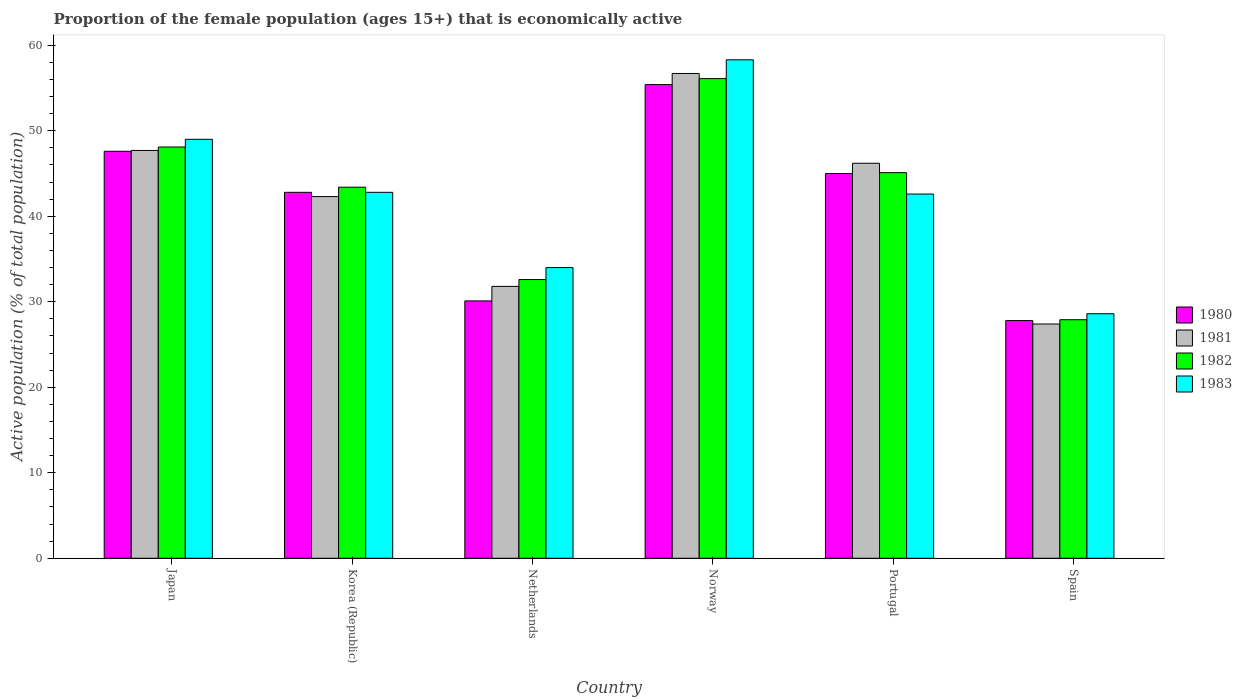How many groups of bars are there?
Offer a terse response. 6. Are the number of bars on each tick of the X-axis equal?
Ensure brevity in your answer.  Yes. What is the proportion of the female population that is economically active in 1981 in Spain?
Provide a short and direct response. 27.4. Across all countries, what is the maximum proportion of the female population that is economically active in 1983?
Your answer should be compact. 58.3. Across all countries, what is the minimum proportion of the female population that is economically active in 1981?
Ensure brevity in your answer.  27.4. What is the total proportion of the female population that is economically active in 1981 in the graph?
Provide a short and direct response. 252.1. What is the difference between the proportion of the female population that is economically active in 1981 in Korea (Republic) and that in Norway?
Your answer should be very brief. -14.4. What is the difference between the proportion of the female population that is economically active in 1980 in Spain and the proportion of the female population that is economically active in 1983 in Japan?
Your answer should be very brief. -21.2. What is the average proportion of the female population that is economically active in 1981 per country?
Give a very brief answer. 42.02. What is the difference between the proportion of the female population that is economically active of/in 1982 and proportion of the female population that is economically active of/in 1981 in Japan?
Your answer should be very brief. 0.4. What is the ratio of the proportion of the female population that is economically active in 1981 in Norway to that in Spain?
Your response must be concise. 2.07. Is the proportion of the female population that is economically active in 1982 in Japan less than that in Korea (Republic)?
Your response must be concise. No. Is the difference between the proportion of the female population that is economically active in 1982 in Japan and Korea (Republic) greater than the difference between the proportion of the female population that is economically active in 1981 in Japan and Korea (Republic)?
Offer a terse response. No. What is the difference between the highest and the second highest proportion of the female population that is economically active in 1980?
Provide a short and direct response. -2.6. What is the difference between the highest and the lowest proportion of the female population that is economically active in 1981?
Give a very brief answer. 29.3. In how many countries, is the proportion of the female population that is economically active in 1983 greater than the average proportion of the female population that is economically active in 1983 taken over all countries?
Offer a very short reply. 4. What does the 2nd bar from the left in Korea (Republic) represents?
Your answer should be very brief. 1981. How many countries are there in the graph?
Provide a succinct answer. 6. What is the difference between two consecutive major ticks on the Y-axis?
Offer a very short reply. 10. Does the graph contain grids?
Your answer should be compact. No. How many legend labels are there?
Make the answer very short. 4. How are the legend labels stacked?
Provide a short and direct response. Vertical. What is the title of the graph?
Offer a very short reply. Proportion of the female population (ages 15+) that is economically active. Does "1983" appear as one of the legend labels in the graph?
Provide a short and direct response. Yes. What is the label or title of the X-axis?
Your answer should be compact. Country. What is the label or title of the Y-axis?
Your answer should be very brief. Active population (% of total population). What is the Active population (% of total population) of 1980 in Japan?
Provide a short and direct response. 47.6. What is the Active population (% of total population) of 1981 in Japan?
Give a very brief answer. 47.7. What is the Active population (% of total population) in 1982 in Japan?
Ensure brevity in your answer.  48.1. What is the Active population (% of total population) of 1983 in Japan?
Your response must be concise. 49. What is the Active population (% of total population) in 1980 in Korea (Republic)?
Your answer should be compact. 42.8. What is the Active population (% of total population) of 1981 in Korea (Republic)?
Give a very brief answer. 42.3. What is the Active population (% of total population) of 1982 in Korea (Republic)?
Give a very brief answer. 43.4. What is the Active population (% of total population) of 1983 in Korea (Republic)?
Keep it short and to the point. 42.8. What is the Active population (% of total population) in 1980 in Netherlands?
Your response must be concise. 30.1. What is the Active population (% of total population) of 1981 in Netherlands?
Ensure brevity in your answer.  31.8. What is the Active population (% of total population) of 1982 in Netherlands?
Make the answer very short. 32.6. What is the Active population (% of total population) in 1983 in Netherlands?
Provide a short and direct response. 34. What is the Active population (% of total population) in 1980 in Norway?
Give a very brief answer. 55.4. What is the Active population (% of total population) in 1981 in Norway?
Ensure brevity in your answer.  56.7. What is the Active population (% of total population) in 1982 in Norway?
Offer a very short reply. 56.1. What is the Active population (% of total population) of 1983 in Norway?
Your response must be concise. 58.3. What is the Active population (% of total population) of 1980 in Portugal?
Your answer should be very brief. 45. What is the Active population (% of total population) of 1981 in Portugal?
Your response must be concise. 46.2. What is the Active population (% of total population) of 1982 in Portugal?
Offer a terse response. 45.1. What is the Active population (% of total population) in 1983 in Portugal?
Keep it short and to the point. 42.6. What is the Active population (% of total population) of 1980 in Spain?
Offer a terse response. 27.8. What is the Active population (% of total population) of 1981 in Spain?
Offer a very short reply. 27.4. What is the Active population (% of total population) in 1982 in Spain?
Provide a short and direct response. 27.9. What is the Active population (% of total population) of 1983 in Spain?
Your answer should be very brief. 28.6. Across all countries, what is the maximum Active population (% of total population) in 1980?
Your answer should be compact. 55.4. Across all countries, what is the maximum Active population (% of total population) of 1981?
Provide a succinct answer. 56.7. Across all countries, what is the maximum Active population (% of total population) in 1982?
Provide a short and direct response. 56.1. Across all countries, what is the maximum Active population (% of total population) in 1983?
Offer a very short reply. 58.3. Across all countries, what is the minimum Active population (% of total population) of 1980?
Keep it short and to the point. 27.8. Across all countries, what is the minimum Active population (% of total population) in 1981?
Provide a succinct answer. 27.4. Across all countries, what is the minimum Active population (% of total population) of 1982?
Ensure brevity in your answer.  27.9. Across all countries, what is the minimum Active population (% of total population) of 1983?
Give a very brief answer. 28.6. What is the total Active population (% of total population) of 1980 in the graph?
Give a very brief answer. 248.7. What is the total Active population (% of total population) of 1981 in the graph?
Your answer should be very brief. 252.1. What is the total Active population (% of total population) of 1982 in the graph?
Ensure brevity in your answer.  253.2. What is the total Active population (% of total population) of 1983 in the graph?
Keep it short and to the point. 255.3. What is the difference between the Active population (% of total population) in 1983 in Japan and that in Korea (Republic)?
Your response must be concise. 6.2. What is the difference between the Active population (% of total population) in 1980 in Japan and that in Netherlands?
Offer a very short reply. 17.5. What is the difference between the Active population (% of total population) of 1982 in Japan and that in Netherlands?
Offer a very short reply. 15.5. What is the difference between the Active population (% of total population) of 1983 in Japan and that in Netherlands?
Give a very brief answer. 15. What is the difference between the Active population (% of total population) in 1980 in Japan and that in Portugal?
Give a very brief answer. 2.6. What is the difference between the Active population (% of total population) of 1982 in Japan and that in Portugal?
Your answer should be compact. 3. What is the difference between the Active population (% of total population) in 1983 in Japan and that in Portugal?
Provide a short and direct response. 6.4. What is the difference between the Active population (% of total population) in 1980 in Japan and that in Spain?
Your response must be concise. 19.8. What is the difference between the Active population (% of total population) in 1981 in Japan and that in Spain?
Provide a succinct answer. 20.3. What is the difference between the Active population (% of total population) in 1982 in Japan and that in Spain?
Offer a very short reply. 20.2. What is the difference between the Active population (% of total population) in 1983 in Japan and that in Spain?
Give a very brief answer. 20.4. What is the difference between the Active population (% of total population) of 1980 in Korea (Republic) and that in Netherlands?
Your response must be concise. 12.7. What is the difference between the Active population (% of total population) of 1980 in Korea (Republic) and that in Norway?
Ensure brevity in your answer.  -12.6. What is the difference between the Active population (% of total population) of 1981 in Korea (Republic) and that in Norway?
Offer a very short reply. -14.4. What is the difference between the Active population (% of total population) of 1982 in Korea (Republic) and that in Norway?
Offer a terse response. -12.7. What is the difference between the Active population (% of total population) in 1983 in Korea (Republic) and that in Norway?
Your answer should be compact. -15.5. What is the difference between the Active population (% of total population) of 1980 in Korea (Republic) and that in Portugal?
Your response must be concise. -2.2. What is the difference between the Active population (% of total population) in 1983 in Korea (Republic) and that in Portugal?
Ensure brevity in your answer.  0.2. What is the difference between the Active population (% of total population) of 1981 in Korea (Republic) and that in Spain?
Make the answer very short. 14.9. What is the difference between the Active population (% of total population) of 1983 in Korea (Republic) and that in Spain?
Give a very brief answer. 14.2. What is the difference between the Active population (% of total population) in 1980 in Netherlands and that in Norway?
Ensure brevity in your answer.  -25.3. What is the difference between the Active population (% of total population) in 1981 in Netherlands and that in Norway?
Provide a succinct answer. -24.9. What is the difference between the Active population (% of total population) of 1982 in Netherlands and that in Norway?
Keep it short and to the point. -23.5. What is the difference between the Active population (% of total population) in 1983 in Netherlands and that in Norway?
Offer a terse response. -24.3. What is the difference between the Active population (% of total population) of 1980 in Netherlands and that in Portugal?
Offer a terse response. -14.9. What is the difference between the Active population (% of total population) in 1981 in Netherlands and that in Portugal?
Make the answer very short. -14.4. What is the difference between the Active population (% of total population) in 1982 in Netherlands and that in Portugal?
Your answer should be very brief. -12.5. What is the difference between the Active population (% of total population) of 1981 in Netherlands and that in Spain?
Offer a terse response. 4.4. What is the difference between the Active population (% of total population) in 1983 in Netherlands and that in Spain?
Your answer should be very brief. 5.4. What is the difference between the Active population (% of total population) of 1980 in Norway and that in Portugal?
Provide a short and direct response. 10.4. What is the difference between the Active population (% of total population) in 1981 in Norway and that in Portugal?
Offer a very short reply. 10.5. What is the difference between the Active population (% of total population) of 1980 in Norway and that in Spain?
Your answer should be very brief. 27.6. What is the difference between the Active population (% of total population) in 1981 in Norway and that in Spain?
Provide a succinct answer. 29.3. What is the difference between the Active population (% of total population) of 1982 in Norway and that in Spain?
Give a very brief answer. 28.2. What is the difference between the Active population (% of total population) of 1983 in Norway and that in Spain?
Ensure brevity in your answer.  29.7. What is the difference between the Active population (% of total population) of 1980 in Portugal and that in Spain?
Give a very brief answer. 17.2. What is the difference between the Active population (% of total population) in 1981 in Portugal and that in Spain?
Ensure brevity in your answer.  18.8. What is the difference between the Active population (% of total population) of 1983 in Portugal and that in Spain?
Offer a very short reply. 14. What is the difference between the Active population (% of total population) of 1981 in Japan and the Active population (% of total population) of 1982 in Korea (Republic)?
Provide a short and direct response. 4.3. What is the difference between the Active population (% of total population) of 1982 in Japan and the Active population (% of total population) of 1983 in Korea (Republic)?
Provide a short and direct response. 5.3. What is the difference between the Active population (% of total population) of 1980 in Japan and the Active population (% of total population) of 1983 in Netherlands?
Make the answer very short. 13.6. What is the difference between the Active population (% of total population) in 1981 in Japan and the Active population (% of total population) in 1983 in Netherlands?
Offer a terse response. 13.7. What is the difference between the Active population (% of total population) in 1980 in Japan and the Active population (% of total population) in 1981 in Norway?
Make the answer very short. -9.1. What is the difference between the Active population (% of total population) in 1980 in Japan and the Active population (% of total population) in 1983 in Norway?
Give a very brief answer. -10.7. What is the difference between the Active population (% of total population) in 1980 in Japan and the Active population (% of total population) in 1981 in Portugal?
Ensure brevity in your answer.  1.4. What is the difference between the Active population (% of total population) of 1980 in Japan and the Active population (% of total population) of 1982 in Portugal?
Provide a succinct answer. 2.5. What is the difference between the Active population (% of total population) of 1980 in Japan and the Active population (% of total population) of 1983 in Portugal?
Make the answer very short. 5. What is the difference between the Active population (% of total population) of 1981 in Japan and the Active population (% of total population) of 1982 in Portugal?
Keep it short and to the point. 2.6. What is the difference between the Active population (% of total population) of 1981 in Japan and the Active population (% of total population) of 1983 in Portugal?
Your answer should be compact. 5.1. What is the difference between the Active population (% of total population) of 1980 in Japan and the Active population (% of total population) of 1981 in Spain?
Provide a short and direct response. 20.2. What is the difference between the Active population (% of total population) in 1980 in Japan and the Active population (% of total population) in 1983 in Spain?
Your response must be concise. 19. What is the difference between the Active population (% of total population) of 1981 in Japan and the Active population (% of total population) of 1982 in Spain?
Your answer should be very brief. 19.8. What is the difference between the Active population (% of total population) in 1981 in Japan and the Active population (% of total population) in 1983 in Spain?
Ensure brevity in your answer.  19.1. What is the difference between the Active population (% of total population) of 1982 in Japan and the Active population (% of total population) of 1983 in Spain?
Your response must be concise. 19.5. What is the difference between the Active population (% of total population) in 1980 in Korea (Republic) and the Active population (% of total population) in 1981 in Netherlands?
Provide a short and direct response. 11. What is the difference between the Active population (% of total population) in 1980 in Korea (Republic) and the Active population (% of total population) in 1983 in Netherlands?
Offer a very short reply. 8.8. What is the difference between the Active population (% of total population) of 1981 in Korea (Republic) and the Active population (% of total population) of 1983 in Netherlands?
Your answer should be very brief. 8.3. What is the difference between the Active population (% of total population) of 1980 in Korea (Republic) and the Active population (% of total population) of 1983 in Norway?
Provide a succinct answer. -15.5. What is the difference between the Active population (% of total population) of 1981 in Korea (Republic) and the Active population (% of total population) of 1982 in Norway?
Your answer should be compact. -13.8. What is the difference between the Active population (% of total population) in 1981 in Korea (Republic) and the Active population (% of total population) in 1983 in Norway?
Your response must be concise. -16. What is the difference between the Active population (% of total population) in 1982 in Korea (Republic) and the Active population (% of total population) in 1983 in Norway?
Offer a very short reply. -14.9. What is the difference between the Active population (% of total population) in 1980 in Korea (Republic) and the Active population (% of total population) in 1981 in Portugal?
Offer a terse response. -3.4. What is the difference between the Active population (% of total population) in 1980 in Korea (Republic) and the Active population (% of total population) in 1982 in Portugal?
Your answer should be compact. -2.3. What is the difference between the Active population (% of total population) of 1980 in Korea (Republic) and the Active population (% of total population) of 1983 in Portugal?
Your answer should be very brief. 0.2. What is the difference between the Active population (% of total population) of 1981 in Korea (Republic) and the Active population (% of total population) of 1982 in Portugal?
Your answer should be compact. -2.8. What is the difference between the Active population (% of total population) in 1981 in Korea (Republic) and the Active population (% of total population) in 1983 in Portugal?
Provide a short and direct response. -0.3. What is the difference between the Active population (% of total population) of 1982 in Korea (Republic) and the Active population (% of total population) of 1983 in Portugal?
Offer a terse response. 0.8. What is the difference between the Active population (% of total population) in 1980 in Korea (Republic) and the Active population (% of total population) in 1981 in Spain?
Offer a very short reply. 15.4. What is the difference between the Active population (% of total population) in 1981 in Korea (Republic) and the Active population (% of total population) in 1983 in Spain?
Ensure brevity in your answer.  13.7. What is the difference between the Active population (% of total population) of 1982 in Korea (Republic) and the Active population (% of total population) of 1983 in Spain?
Offer a very short reply. 14.8. What is the difference between the Active population (% of total population) in 1980 in Netherlands and the Active population (% of total population) in 1981 in Norway?
Offer a very short reply. -26.6. What is the difference between the Active population (% of total population) in 1980 in Netherlands and the Active population (% of total population) in 1982 in Norway?
Offer a very short reply. -26. What is the difference between the Active population (% of total population) in 1980 in Netherlands and the Active population (% of total population) in 1983 in Norway?
Make the answer very short. -28.2. What is the difference between the Active population (% of total population) in 1981 in Netherlands and the Active population (% of total population) in 1982 in Norway?
Provide a succinct answer. -24.3. What is the difference between the Active population (% of total population) in 1981 in Netherlands and the Active population (% of total population) in 1983 in Norway?
Provide a short and direct response. -26.5. What is the difference between the Active population (% of total population) in 1982 in Netherlands and the Active population (% of total population) in 1983 in Norway?
Offer a terse response. -25.7. What is the difference between the Active population (% of total population) of 1980 in Netherlands and the Active population (% of total population) of 1981 in Portugal?
Your response must be concise. -16.1. What is the difference between the Active population (% of total population) of 1980 in Netherlands and the Active population (% of total population) of 1981 in Spain?
Offer a very short reply. 2.7. What is the difference between the Active population (% of total population) of 1980 in Netherlands and the Active population (% of total population) of 1983 in Spain?
Your answer should be very brief. 1.5. What is the difference between the Active population (% of total population) of 1981 in Netherlands and the Active population (% of total population) of 1982 in Spain?
Your answer should be very brief. 3.9. What is the difference between the Active population (% of total population) of 1980 in Norway and the Active population (% of total population) of 1981 in Portugal?
Your response must be concise. 9.2. What is the difference between the Active population (% of total population) of 1980 in Norway and the Active population (% of total population) of 1983 in Portugal?
Your answer should be compact. 12.8. What is the difference between the Active population (% of total population) of 1981 in Norway and the Active population (% of total population) of 1982 in Portugal?
Make the answer very short. 11.6. What is the difference between the Active population (% of total population) in 1981 in Norway and the Active population (% of total population) in 1983 in Portugal?
Provide a short and direct response. 14.1. What is the difference between the Active population (% of total population) in 1982 in Norway and the Active population (% of total population) in 1983 in Portugal?
Give a very brief answer. 13.5. What is the difference between the Active population (% of total population) of 1980 in Norway and the Active population (% of total population) of 1981 in Spain?
Provide a succinct answer. 28. What is the difference between the Active population (% of total population) of 1980 in Norway and the Active population (% of total population) of 1983 in Spain?
Give a very brief answer. 26.8. What is the difference between the Active population (% of total population) of 1981 in Norway and the Active population (% of total population) of 1982 in Spain?
Offer a very short reply. 28.8. What is the difference between the Active population (% of total population) of 1981 in Norway and the Active population (% of total population) of 1983 in Spain?
Keep it short and to the point. 28.1. What is the difference between the Active population (% of total population) in 1982 in Norway and the Active population (% of total population) in 1983 in Spain?
Make the answer very short. 27.5. What is the difference between the Active population (% of total population) of 1980 in Portugal and the Active population (% of total population) of 1981 in Spain?
Offer a terse response. 17.6. What is the difference between the Active population (% of total population) in 1980 in Portugal and the Active population (% of total population) in 1983 in Spain?
Keep it short and to the point. 16.4. What is the difference between the Active population (% of total population) in 1981 in Portugal and the Active population (% of total population) in 1982 in Spain?
Provide a succinct answer. 18.3. What is the difference between the Active population (% of total population) in 1982 in Portugal and the Active population (% of total population) in 1983 in Spain?
Offer a terse response. 16.5. What is the average Active population (% of total population) in 1980 per country?
Offer a very short reply. 41.45. What is the average Active population (% of total population) in 1981 per country?
Your answer should be compact. 42.02. What is the average Active population (% of total population) of 1982 per country?
Your response must be concise. 42.2. What is the average Active population (% of total population) of 1983 per country?
Your response must be concise. 42.55. What is the difference between the Active population (% of total population) of 1980 and Active population (% of total population) of 1981 in Japan?
Give a very brief answer. -0.1. What is the difference between the Active population (% of total population) in 1980 and Active population (% of total population) in 1982 in Japan?
Make the answer very short. -0.5. What is the difference between the Active population (% of total population) of 1982 and Active population (% of total population) of 1983 in Japan?
Give a very brief answer. -0.9. What is the difference between the Active population (% of total population) in 1980 and Active population (% of total population) in 1981 in Korea (Republic)?
Keep it short and to the point. 0.5. What is the difference between the Active population (% of total population) of 1981 and Active population (% of total population) of 1983 in Korea (Republic)?
Provide a short and direct response. -0.5. What is the difference between the Active population (% of total population) of 1980 and Active population (% of total population) of 1983 in Netherlands?
Your response must be concise. -3.9. What is the difference between the Active population (% of total population) in 1981 and Active population (% of total population) in 1982 in Netherlands?
Keep it short and to the point. -0.8. What is the difference between the Active population (% of total population) in 1981 and Active population (% of total population) in 1983 in Netherlands?
Your answer should be compact. -2.2. What is the difference between the Active population (% of total population) of 1982 and Active population (% of total population) of 1983 in Netherlands?
Your answer should be very brief. -1.4. What is the difference between the Active population (% of total population) in 1981 and Active population (% of total population) in 1982 in Norway?
Provide a succinct answer. 0.6. What is the difference between the Active population (% of total population) of 1980 and Active population (% of total population) of 1983 in Portugal?
Provide a short and direct response. 2.4. What is the difference between the Active population (% of total population) of 1981 and Active population (% of total population) of 1982 in Portugal?
Provide a succinct answer. 1.1. What is the difference between the Active population (% of total population) in 1982 and Active population (% of total population) in 1983 in Portugal?
Provide a short and direct response. 2.5. What is the difference between the Active population (% of total population) of 1980 and Active population (% of total population) of 1981 in Spain?
Offer a very short reply. 0.4. What is the difference between the Active population (% of total population) of 1980 and Active population (% of total population) of 1982 in Spain?
Your response must be concise. -0.1. What is the difference between the Active population (% of total population) of 1981 and Active population (% of total population) of 1982 in Spain?
Provide a short and direct response. -0.5. What is the difference between the Active population (% of total population) of 1981 and Active population (% of total population) of 1983 in Spain?
Your answer should be very brief. -1.2. What is the ratio of the Active population (% of total population) of 1980 in Japan to that in Korea (Republic)?
Make the answer very short. 1.11. What is the ratio of the Active population (% of total population) of 1981 in Japan to that in Korea (Republic)?
Provide a succinct answer. 1.13. What is the ratio of the Active population (% of total population) of 1982 in Japan to that in Korea (Republic)?
Your response must be concise. 1.11. What is the ratio of the Active population (% of total population) in 1983 in Japan to that in Korea (Republic)?
Your response must be concise. 1.14. What is the ratio of the Active population (% of total population) in 1980 in Japan to that in Netherlands?
Your answer should be very brief. 1.58. What is the ratio of the Active population (% of total population) of 1982 in Japan to that in Netherlands?
Your response must be concise. 1.48. What is the ratio of the Active population (% of total population) in 1983 in Japan to that in Netherlands?
Give a very brief answer. 1.44. What is the ratio of the Active population (% of total population) in 1980 in Japan to that in Norway?
Provide a short and direct response. 0.86. What is the ratio of the Active population (% of total population) of 1981 in Japan to that in Norway?
Provide a succinct answer. 0.84. What is the ratio of the Active population (% of total population) of 1982 in Japan to that in Norway?
Provide a succinct answer. 0.86. What is the ratio of the Active population (% of total population) of 1983 in Japan to that in Norway?
Ensure brevity in your answer.  0.84. What is the ratio of the Active population (% of total population) of 1980 in Japan to that in Portugal?
Make the answer very short. 1.06. What is the ratio of the Active population (% of total population) in 1981 in Japan to that in Portugal?
Ensure brevity in your answer.  1.03. What is the ratio of the Active population (% of total population) in 1982 in Japan to that in Portugal?
Make the answer very short. 1.07. What is the ratio of the Active population (% of total population) of 1983 in Japan to that in Portugal?
Provide a succinct answer. 1.15. What is the ratio of the Active population (% of total population) in 1980 in Japan to that in Spain?
Offer a very short reply. 1.71. What is the ratio of the Active population (% of total population) of 1981 in Japan to that in Spain?
Make the answer very short. 1.74. What is the ratio of the Active population (% of total population) in 1982 in Japan to that in Spain?
Keep it short and to the point. 1.72. What is the ratio of the Active population (% of total population) of 1983 in Japan to that in Spain?
Ensure brevity in your answer.  1.71. What is the ratio of the Active population (% of total population) in 1980 in Korea (Republic) to that in Netherlands?
Keep it short and to the point. 1.42. What is the ratio of the Active population (% of total population) of 1981 in Korea (Republic) to that in Netherlands?
Offer a terse response. 1.33. What is the ratio of the Active population (% of total population) in 1982 in Korea (Republic) to that in Netherlands?
Give a very brief answer. 1.33. What is the ratio of the Active population (% of total population) of 1983 in Korea (Republic) to that in Netherlands?
Offer a terse response. 1.26. What is the ratio of the Active population (% of total population) in 1980 in Korea (Republic) to that in Norway?
Offer a terse response. 0.77. What is the ratio of the Active population (% of total population) of 1981 in Korea (Republic) to that in Norway?
Your answer should be very brief. 0.75. What is the ratio of the Active population (% of total population) in 1982 in Korea (Republic) to that in Norway?
Provide a short and direct response. 0.77. What is the ratio of the Active population (% of total population) in 1983 in Korea (Republic) to that in Norway?
Make the answer very short. 0.73. What is the ratio of the Active population (% of total population) of 1980 in Korea (Republic) to that in Portugal?
Your response must be concise. 0.95. What is the ratio of the Active population (% of total population) in 1981 in Korea (Republic) to that in Portugal?
Give a very brief answer. 0.92. What is the ratio of the Active population (% of total population) of 1982 in Korea (Republic) to that in Portugal?
Give a very brief answer. 0.96. What is the ratio of the Active population (% of total population) in 1983 in Korea (Republic) to that in Portugal?
Provide a short and direct response. 1. What is the ratio of the Active population (% of total population) in 1980 in Korea (Republic) to that in Spain?
Make the answer very short. 1.54. What is the ratio of the Active population (% of total population) of 1981 in Korea (Republic) to that in Spain?
Make the answer very short. 1.54. What is the ratio of the Active population (% of total population) of 1982 in Korea (Republic) to that in Spain?
Your response must be concise. 1.56. What is the ratio of the Active population (% of total population) of 1983 in Korea (Republic) to that in Spain?
Your answer should be compact. 1.5. What is the ratio of the Active population (% of total population) in 1980 in Netherlands to that in Norway?
Ensure brevity in your answer.  0.54. What is the ratio of the Active population (% of total population) in 1981 in Netherlands to that in Norway?
Keep it short and to the point. 0.56. What is the ratio of the Active population (% of total population) in 1982 in Netherlands to that in Norway?
Keep it short and to the point. 0.58. What is the ratio of the Active population (% of total population) of 1983 in Netherlands to that in Norway?
Your response must be concise. 0.58. What is the ratio of the Active population (% of total population) in 1980 in Netherlands to that in Portugal?
Your answer should be very brief. 0.67. What is the ratio of the Active population (% of total population) of 1981 in Netherlands to that in Portugal?
Offer a very short reply. 0.69. What is the ratio of the Active population (% of total population) in 1982 in Netherlands to that in Portugal?
Provide a succinct answer. 0.72. What is the ratio of the Active population (% of total population) of 1983 in Netherlands to that in Portugal?
Ensure brevity in your answer.  0.8. What is the ratio of the Active population (% of total population) in 1980 in Netherlands to that in Spain?
Ensure brevity in your answer.  1.08. What is the ratio of the Active population (% of total population) of 1981 in Netherlands to that in Spain?
Provide a succinct answer. 1.16. What is the ratio of the Active population (% of total population) of 1982 in Netherlands to that in Spain?
Give a very brief answer. 1.17. What is the ratio of the Active population (% of total population) in 1983 in Netherlands to that in Spain?
Offer a terse response. 1.19. What is the ratio of the Active population (% of total population) in 1980 in Norway to that in Portugal?
Your answer should be compact. 1.23. What is the ratio of the Active population (% of total population) in 1981 in Norway to that in Portugal?
Offer a terse response. 1.23. What is the ratio of the Active population (% of total population) in 1982 in Norway to that in Portugal?
Offer a very short reply. 1.24. What is the ratio of the Active population (% of total population) in 1983 in Norway to that in Portugal?
Your answer should be very brief. 1.37. What is the ratio of the Active population (% of total population) in 1980 in Norway to that in Spain?
Provide a succinct answer. 1.99. What is the ratio of the Active population (% of total population) in 1981 in Norway to that in Spain?
Make the answer very short. 2.07. What is the ratio of the Active population (% of total population) of 1982 in Norway to that in Spain?
Your response must be concise. 2.01. What is the ratio of the Active population (% of total population) of 1983 in Norway to that in Spain?
Offer a very short reply. 2.04. What is the ratio of the Active population (% of total population) of 1980 in Portugal to that in Spain?
Give a very brief answer. 1.62. What is the ratio of the Active population (% of total population) in 1981 in Portugal to that in Spain?
Provide a succinct answer. 1.69. What is the ratio of the Active population (% of total population) in 1982 in Portugal to that in Spain?
Provide a short and direct response. 1.62. What is the ratio of the Active population (% of total population) in 1983 in Portugal to that in Spain?
Keep it short and to the point. 1.49. What is the difference between the highest and the second highest Active population (% of total population) in 1981?
Your answer should be very brief. 9. What is the difference between the highest and the lowest Active population (% of total population) of 1980?
Give a very brief answer. 27.6. What is the difference between the highest and the lowest Active population (% of total population) in 1981?
Keep it short and to the point. 29.3. What is the difference between the highest and the lowest Active population (% of total population) in 1982?
Offer a very short reply. 28.2. What is the difference between the highest and the lowest Active population (% of total population) in 1983?
Offer a terse response. 29.7. 